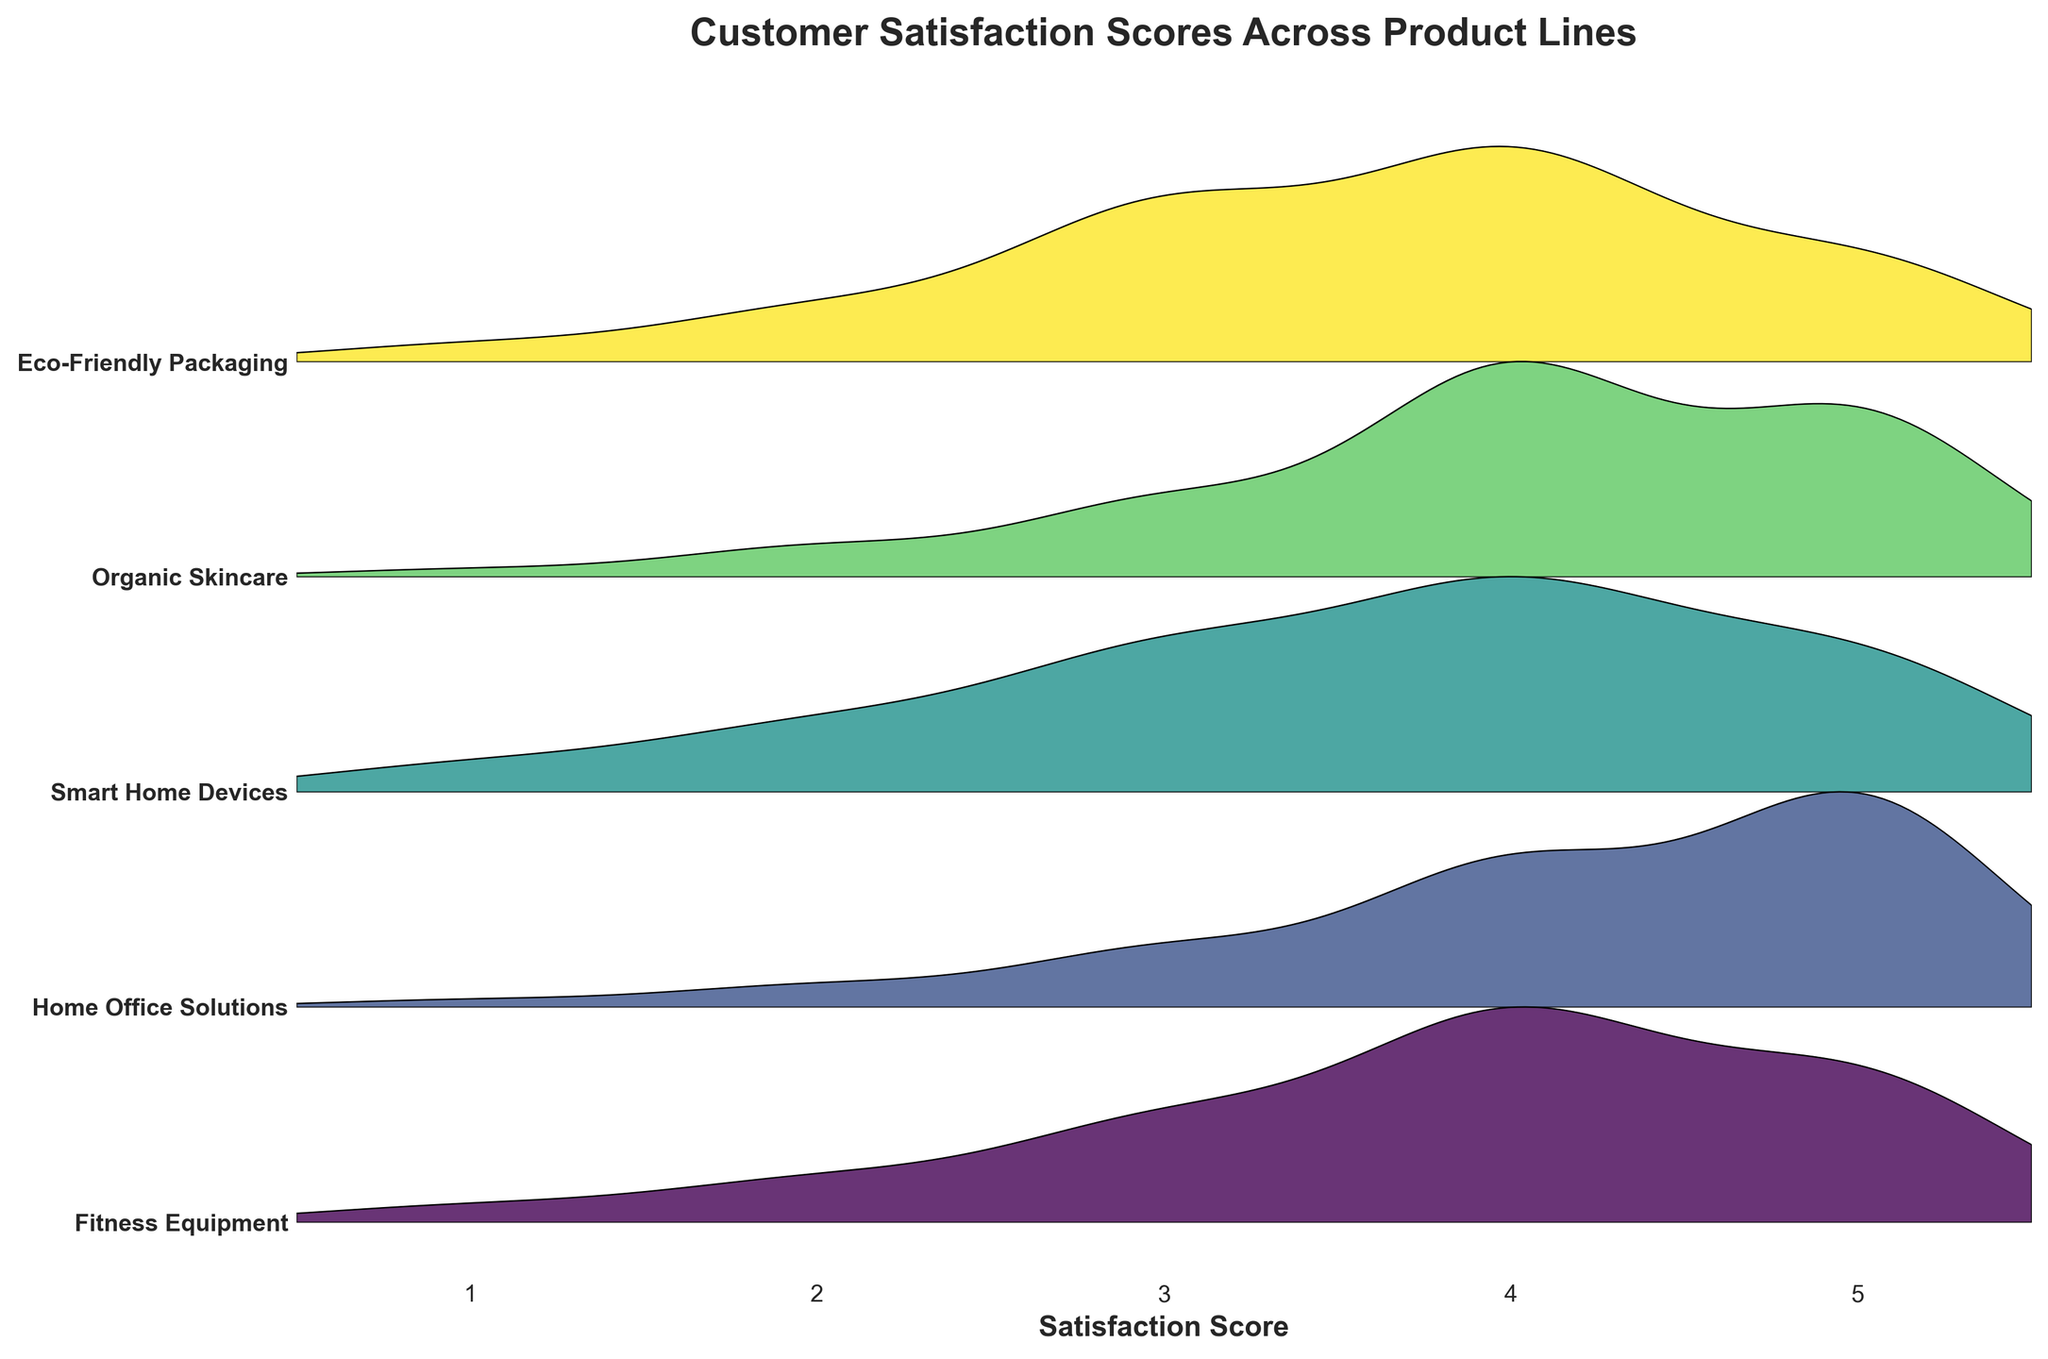Which product line has the highest peak in customer satisfaction scores? The highest peak on the plot represents the product line with the most concentrated high scores. By observing the plot, we can see that Home Office Solutions has the highest peak, indicating the highest concentration of satisfaction scores around the maximum value.
Answer: Home Office Solutions How many product lines show a peak at satisfaction score 5? Checking each ridgeline, we see that both Home Office Solutions and Organic Skincare have significant peaks at satisfaction score 5.
Answer: 2 Which product line has a broader spread of satisfaction scores? To determine this, we assess the width of the spread of each ridgeline plot. Smart Home Devices and Eco-Friendly Packaging both show wider distributions, but Smart Home Devices is slightly broader.
Answer: Smart Home Devices Is there any product line with a noticeable positive skew in the satisfaction scores? Positive skew means more scores are concentrated on the lower end with a long tail toward higher scores. Fitness Equipment shows a noticeable positive skew, with most of its scores at 4 and below and a smaller number at 5.
Answer: Fitness Equipment Which product line stands out for having the least variety in customer satisfaction scores? By examining the plot, Home Office Solutions appears to have the most concentrated distribution near higher scores (4 and 5), meaning less variability.
Answer: Home Office Solutions Among the different product lines, which ones have a peak at satisfaction score 4? Observing the ridgelines, Fitness Equipment, Smart Home Devices, Organic Skincare, and Eco-Friendly Packaging all peak around satisfaction score 4.
Answer: 4 How does the distribution of satisfaction scores for Smart Home Devices compare to that of Eco-Friendly Packaging? Both ridgelines are relatively broad, indicating varied satisfaction scores, but Smart Home Devices has a higher concentration around scores 3 and 4, whereas Eco-Friendly Packaging shows a relatively uniform spread between 2 and 5.
Answer: Smart Home Devices is slightly more concentrated around the middle scores (3 and 4) What can be inferred about the satisfaction levels of Organic Skincare compared to Fitness Equipment? Organic Skincare has a notable concentration of high satisfaction scores (4 and 5), whereas Fitness Equipment has a more evenly distributed spread, with a positive skew indicating higher variability and more lower scores.
Answer: Organic Skincare generally has higher satisfaction levels How many product lines include a peak that touches satisfaction score 3? Examining the ridgelines, Home Office Solutions, Smart Home Devices, and Eco-Friendly Packaging each have significant portions of their distribution touching the score 3.
Answer: 3 